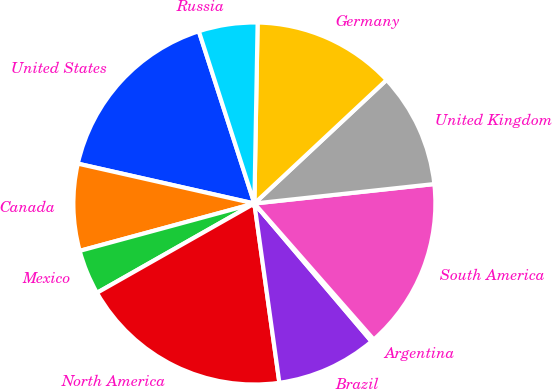<chart> <loc_0><loc_0><loc_500><loc_500><pie_chart><fcel>United States<fcel>Canada<fcel>Mexico<fcel>North America<fcel>Brazil<fcel>Argentina<fcel>South America<fcel>United Kingdom<fcel>Germany<fcel>Russia<nl><fcel>16.5%<fcel>7.75%<fcel>4.0%<fcel>18.99%<fcel>9.0%<fcel>0.26%<fcel>15.25%<fcel>10.25%<fcel>12.75%<fcel>5.25%<nl></chart> 